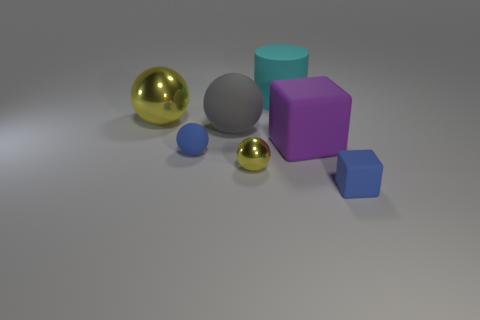Subtract all gray spheres. Subtract all yellow blocks. How many spheres are left? 3 Add 3 cyan cylinders. How many objects exist? 10 Subtract all cylinders. How many objects are left? 6 Subtract 0 brown cylinders. How many objects are left? 7 Subtract all big green rubber blocks. Subtract all large things. How many objects are left? 3 Add 6 blue blocks. How many blue blocks are left? 7 Add 1 large cyan cylinders. How many large cyan cylinders exist? 2 